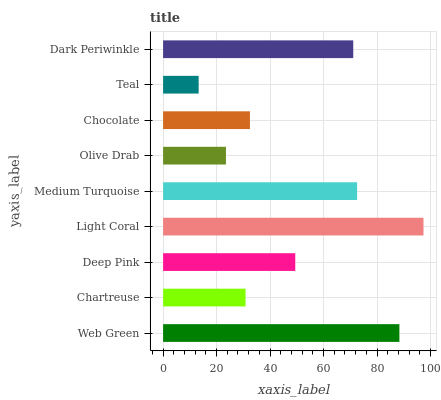Is Teal the minimum?
Answer yes or no. Yes. Is Light Coral the maximum?
Answer yes or no. Yes. Is Chartreuse the minimum?
Answer yes or no. No. Is Chartreuse the maximum?
Answer yes or no. No. Is Web Green greater than Chartreuse?
Answer yes or no. Yes. Is Chartreuse less than Web Green?
Answer yes or no. Yes. Is Chartreuse greater than Web Green?
Answer yes or no. No. Is Web Green less than Chartreuse?
Answer yes or no. No. Is Deep Pink the high median?
Answer yes or no. Yes. Is Deep Pink the low median?
Answer yes or no. Yes. Is Web Green the high median?
Answer yes or no. No. Is Chocolate the low median?
Answer yes or no. No. 